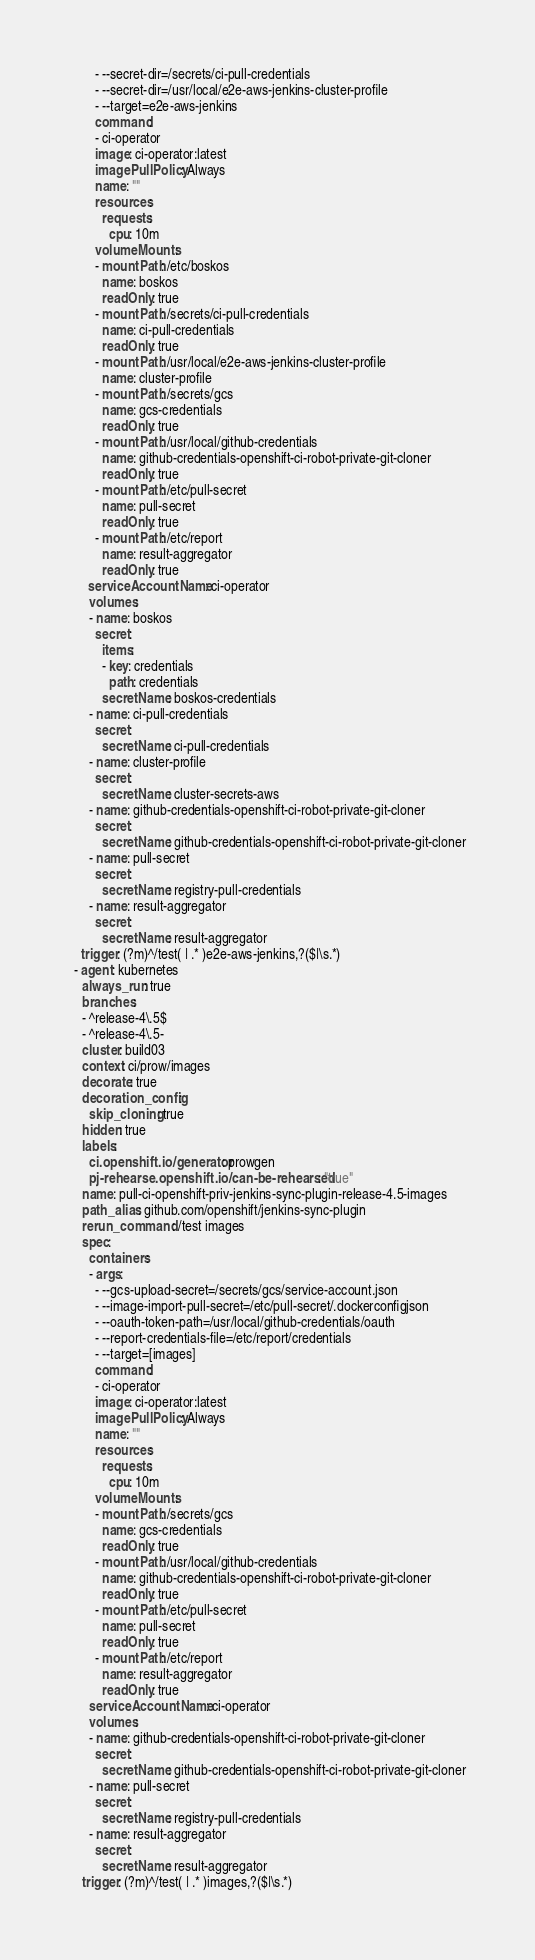Convert code to text. <code><loc_0><loc_0><loc_500><loc_500><_YAML_>        - --secret-dir=/secrets/ci-pull-credentials
        - --secret-dir=/usr/local/e2e-aws-jenkins-cluster-profile
        - --target=e2e-aws-jenkins
        command:
        - ci-operator
        image: ci-operator:latest
        imagePullPolicy: Always
        name: ""
        resources:
          requests:
            cpu: 10m
        volumeMounts:
        - mountPath: /etc/boskos
          name: boskos
          readOnly: true
        - mountPath: /secrets/ci-pull-credentials
          name: ci-pull-credentials
          readOnly: true
        - mountPath: /usr/local/e2e-aws-jenkins-cluster-profile
          name: cluster-profile
        - mountPath: /secrets/gcs
          name: gcs-credentials
          readOnly: true
        - mountPath: /usr/local/github-credentials
          name: github-credentials-openshift-ci-robot-private-git-cloner
          readOnly: true
        - mountPath: /etc/pull-secret
          name: pull-secret
          readOnly: true
        - mountPath: /etc/report
          name: result-aggregator
          readOnly: true
      serviceAccountName: ci-operator
      volumes:
      - name: boskos
        secret:
          items:
          - key: credentials
            path: credentials
          secretName: boskos-credentials
      - name: ci-pull-credentials
        secret:
          secretName: ci-pull-credentials
      - name: cluster-profile
        secret:
          secretName: cluster-secrets-aws
      - name: github-credentials-openshift-ci-robot-private-git-cloner
        secret:
          secretName: github-credentials-openshift-ci-robot-private-git-cloner
      - name: pull-secret
        secret:
          secretName: registry-pull-credentials
      - name: result-aggregator
        secret:
          secretName: result-aggregator
    trigger: (?m)^/test( | .* )e2e-aws-jenkins,?($|\s.*)
  - agent: kubernetes
    always_run: true
    branches:
    - ^release-4\.5$
    - ^release-4\.5-
    cluster: build03
    context: ci/prow/images
    decorate: true
    decoration_config:
      skip_cloning: true
    hidden: true
    labels:
      ci.openshift.io/generator: prowgen
      pj-rehearse.openshift.io/can-be-rehearsed: "true"
    name: pull-ci-openshift-priv-jenkins-sync-plugin-release-4.5-images
    path_alias: github.com/openshift/jenkins-sync-plugin
    rerun_command: /test images
    spec:
      containers:
      - args:
        - --gcs-upload-secret=/secrets/gcs/service-account.json
        - --image-import-pull-secret=/etc/pull-secret/.dockerconfigjson
        - --oauth-token-path=/usr/local/github-credentials/oauth
        - --report-credentials-file=/etc/report/credentials
        - --target=[images]
        command:
        - ci-operator
        image: ci-operator:latest
        imagePullPolicy: Always
        name: ""
        resources:
          requests:
            cpu: 10m
        volumeMounts:
        - mountPath: /secrets/gcs
          name: gcs-credentials
          readOnly: true
        - mountPath: /usr/local/github-credentials
          name: github-credentials-openshift-ci-robot-private-git-cloner
          readOnly: true
        - mountPath: /etc/pull-secret
          name: pull-secret
          readOnly: true
        - mountPath: /etc/report
          name: result-aggregator
          readOnly: true
      serviceAccountName: ci-operator
      volumes:
      - name: github-credentials-openshift-ci-robot-private-git-cloner
        secret:
          secretName: github-credentials-openshift-ci-robot-private-git-cloner
      - name: pull-secret
        secret:
          secretName: registry-pull-credentials
      - name: result-aggregator
        secret:
          secretName: result-aggregator
    trigger: (?m)^/test( | .* )images,?($|\s.*)
</code> 